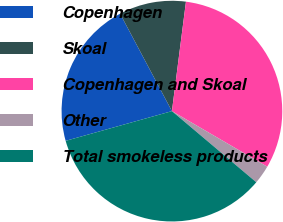Convert chart to OTSL. <chart><loc_0><loc_0><loc_500><loc_500><pie_chart><fcel>Copenhagen<fcel>Skoal<fcel>Copenhagen and Skoal<fcel>Other<fcel>Total smokeless products<nl><fcel>21.56%<fcel>9.81%<fcel>31.37%<fcel>2.75%<fcel>34.51%<nl></chart> 